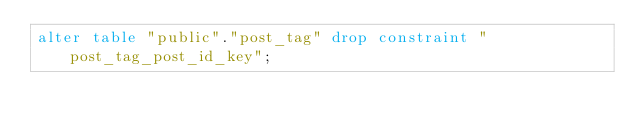Convert code to text. <code><loc_0><loc_0><loc_500><loc_500><_SQL_>alter table "public"."post_tag" drop constraint "post_tag_post_id_key";
</code> 